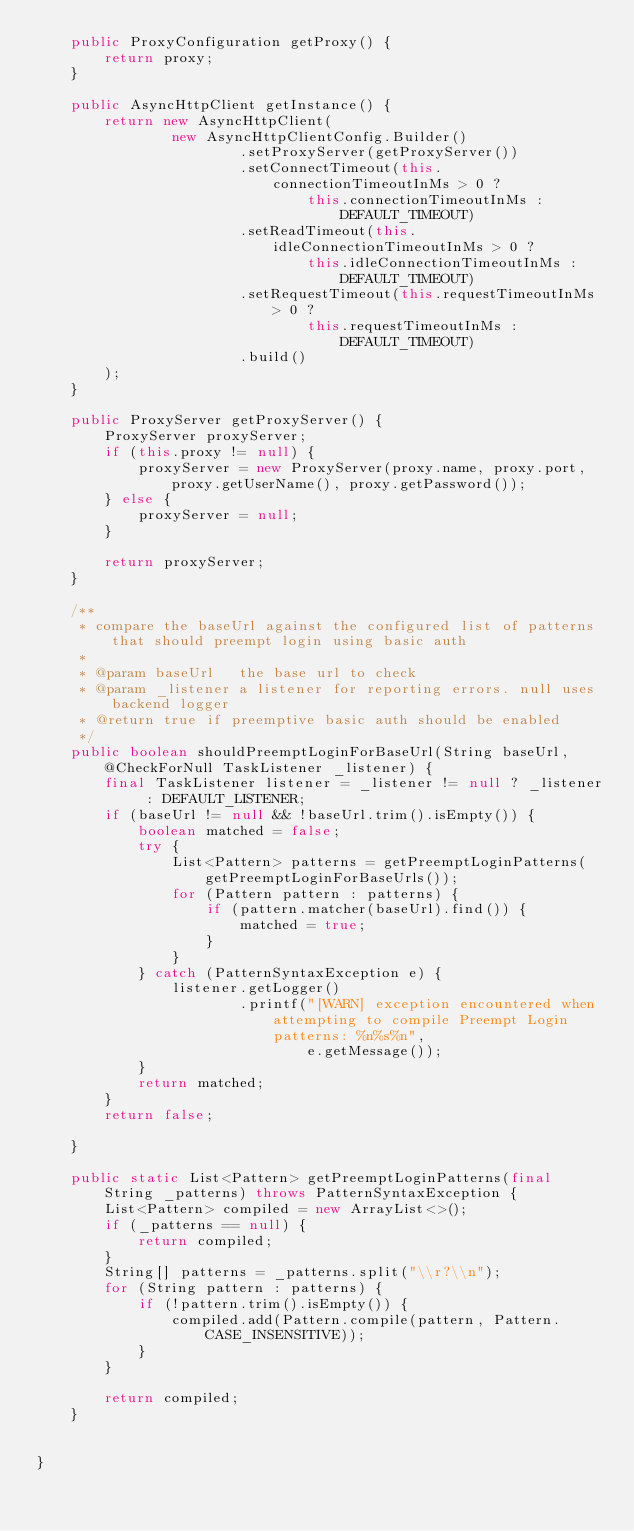<code> <loc_0><loc_0><loc_500><loc_500><_Java_>    public ProxyConfiguration getProxy() {
        return proxy;
    }

    public AsyncHttpClient getInstance() {
        return new AsyncHttpClient(
                new AsyncHttpClientConfig.Builder()
                        .setProxyServer(getProxyServer())
                        .setConnectTimeout(this.connectionTimeoutInMs > 0 ?
                                this.connectionTimeoutInMs : DEFAULT_TIMEOUT)
                        .setReadTimeout(this.idleConnectionTimeoutInMs > 0 ?
                                this.idleConnectionTimeoutInMs : DEFAULT_TIMEOUT)
                        .setRequestTimeout(this.requestTimeoutInMs > 0 ?
                                this.requestTimeoutInMs : DEFAULT_TIMEOUT)
                        .build()
        );
    }

    public ProxyServer getProxyServer() {
        ProxyServer proxyServer;
        if (this.proxy != null) {
            proxyServer = new ProxyServer(proxy.name, proxy.port, proxy.getUserName(), proxy.getPassword());
        } else {
            proxyServer = null;
        }

        return proxyServer;
    }

    /**
     * compare the baseUrl against the configured list of patterns that should preempt login using basic auth
     *
     * @param baseUrl   the base url to check
     * @param _listener a listener for reporting errors. null uses backend logger
     * @return true if preemptive basic auth should be enabled
     */
    public boolean shouldPreemptLoginForBaseUrl(String baseUrl, @CheckForNull TaskListener _listener) {
        final TaskListener listener = _listener != null ? _listener : DEFAULT_LISTENER;
        if (baseUrl != null && !baseUrl.trim().isEmpty()) {
            boolean matched = false;
            try {
                List<Pattern> patterns = getPreemptLoginPatterns(getPreemptLoginForBaseUrls());
                for (Pattern pattern : patterns) {
                    if (pattern.matcher(baseUrl).find()) {
                        matched = true;
                    }
                }
            } catch (PatternSyntaxException e) {
                listener.getLogger()
                        .printf("[WARN] exception encountered when attempting to compile Preempt Login patterns: %n%s%n",
                                e.getMessage());
            }
            return matched;
        }
        return false;

    }

    public static List<Pattern> getPreemptLoginPatterns(final String _patterns) throws PatternSyntaxException {
        List<Pattern> compiled = new ArrayList<>();
        if (_patterns == null) {
            return compiled;
        }
        String[] patterns = _patterns.split("\\r?\\n");
        for (String pattern : patterns) {
            if (!pattern.trim().isEmpty()) {
                compiled.add(Pattern.compile(pattern, Pattern.CASE_INSENSITIVE));
            }
        }

        return compiled;
    }


}
</code> 